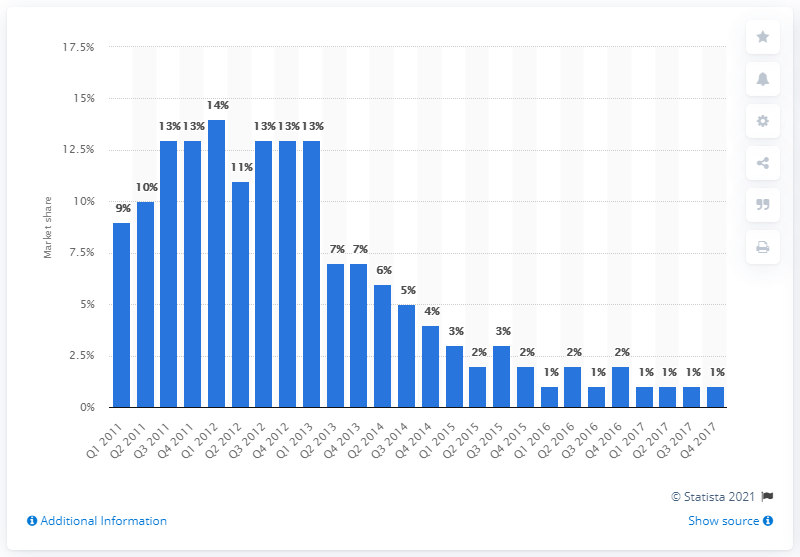Highlight a few significant elements in this photo. In the fourth quarter of 2017, BlackBerry penetration in Britain was 14%. In the fourth quarter of 2017, BlackBerry's market share in Great Britain was 14%. In the first quarter of 2012, BlackBerry's market share was 14%. 